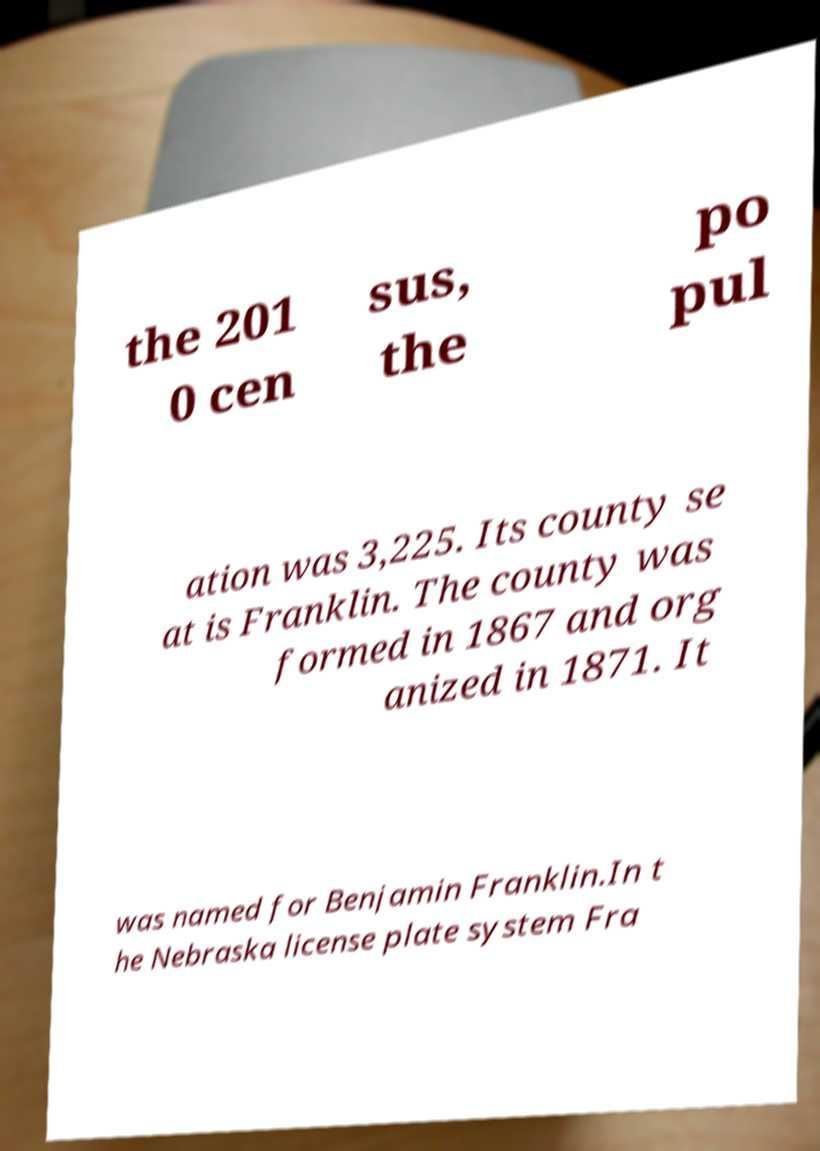Could you assist in decoding the text presented in this image and type it out clearly? the 201 0 cen sus, the po pul ation was 3,225. Its county se at is Franklin. The county was formed in 1867 and org anized in 1871. It was named for Benjamin Franklin.In t he Nebraska license plate system Fra 